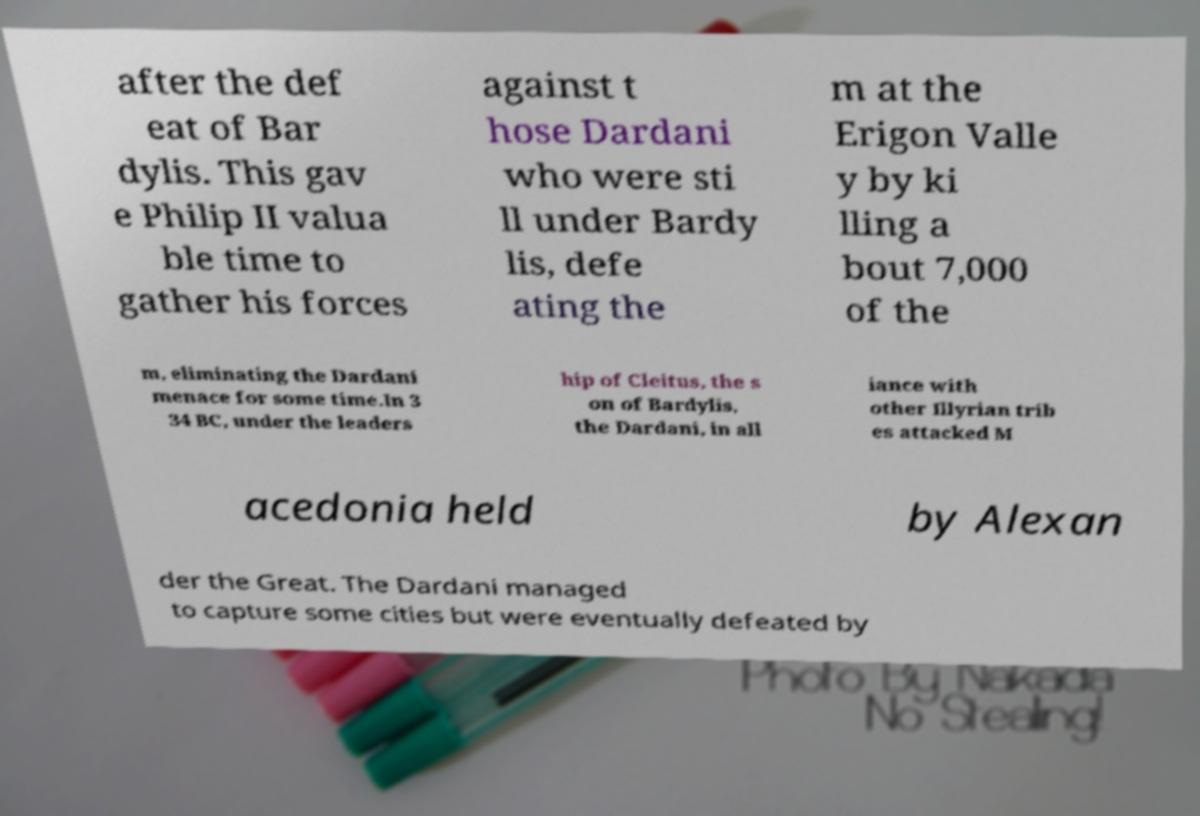I need the written content from this picture converted into text. Can you do that? after the def eat of Bar dylis. This gav e Philip II valua ble time to gather his forces against t hose Dardani who were sti ll under Bardy lis, defe ating the m at the Erigon Valle y by ki lling a bout 7,000 of the m, eliminating the Dardani menace for some time.In 3 34 BC, under the leaders hip of Cleitus, the s on of Bardylis, the Dardani, in all iance with other Illyrian trib es attacked M acedonia held by Alexan der the Great. The Dardani managed to capture some cities but were eventually defeated by 